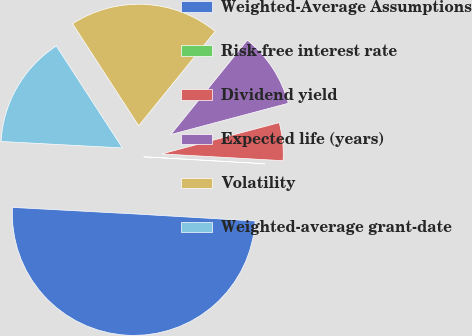Convert chart to OTSL. <chart><loc_0><loc_0><loc_500><loc_500><pie_chart><fcel>Weighted-Average Assumptions<fcel>Risk-free interest rate<fcel>Dividend yield<fcel>Expected life (years)<fcel>Volatility<fcel>Weighted-average grant-date<nl><fcel>49.92%<fcel>0.04%<fcel>5.03%<fcel>10.02%<fcel>19.99%<fcel>15.0%<nl></chart> 